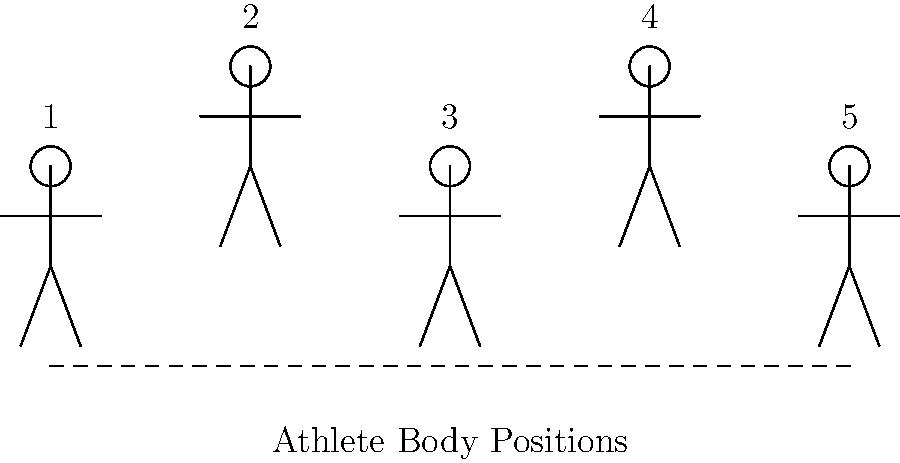In the image depicting various athlete body positions, which stance is most likely to provide the optimal starting position for a 100-meter sprint, considering the biomechanics of explosive acceleration? To determine the optimal starting position for a 100-meter sprint, we need to consider the biomechanics of explosive acceleration. Let's analyze each position:

1. Position 1: The athlete appears to be standing upright, which is not ideal for quick starts.
2. Position 2: The athlete is slightly bent forward, which is better than position 1 but not optimal.
3. Position 3: This position shows the athlete in a crouched stance, with the body leaning forward and arms bent. This is the most favorable position for explosive starts.
4. Position 4: Similar to position 2, it's better than standing upright but not as effective as position 3.
5. Position 5: The athlete appears to be in a relaxed stance, which is not suitable for quick starts.

Position 3 is optimal because:
- The crouched stance lowers the center of gravity, improving stability.
- The forward lean positions the body to push backward against the starting blocks more effectively.
- The bent arms allow for a powerful arm drive at the start, contributing to initial acceleration.
- This position enables the sprinter to rapidly transition from a stationary position to explosive movement, maximizing the conversion of potential energy to kinetic energy.

In sprinting biomechanics, this position is known as the "set" position in the starting blocks, which has been proven to be the most effective for initiating a powerful drive phase and achieving maximum acceleration in the crucial first few steps of a 100-meter sprint.
Answer: Position 3 